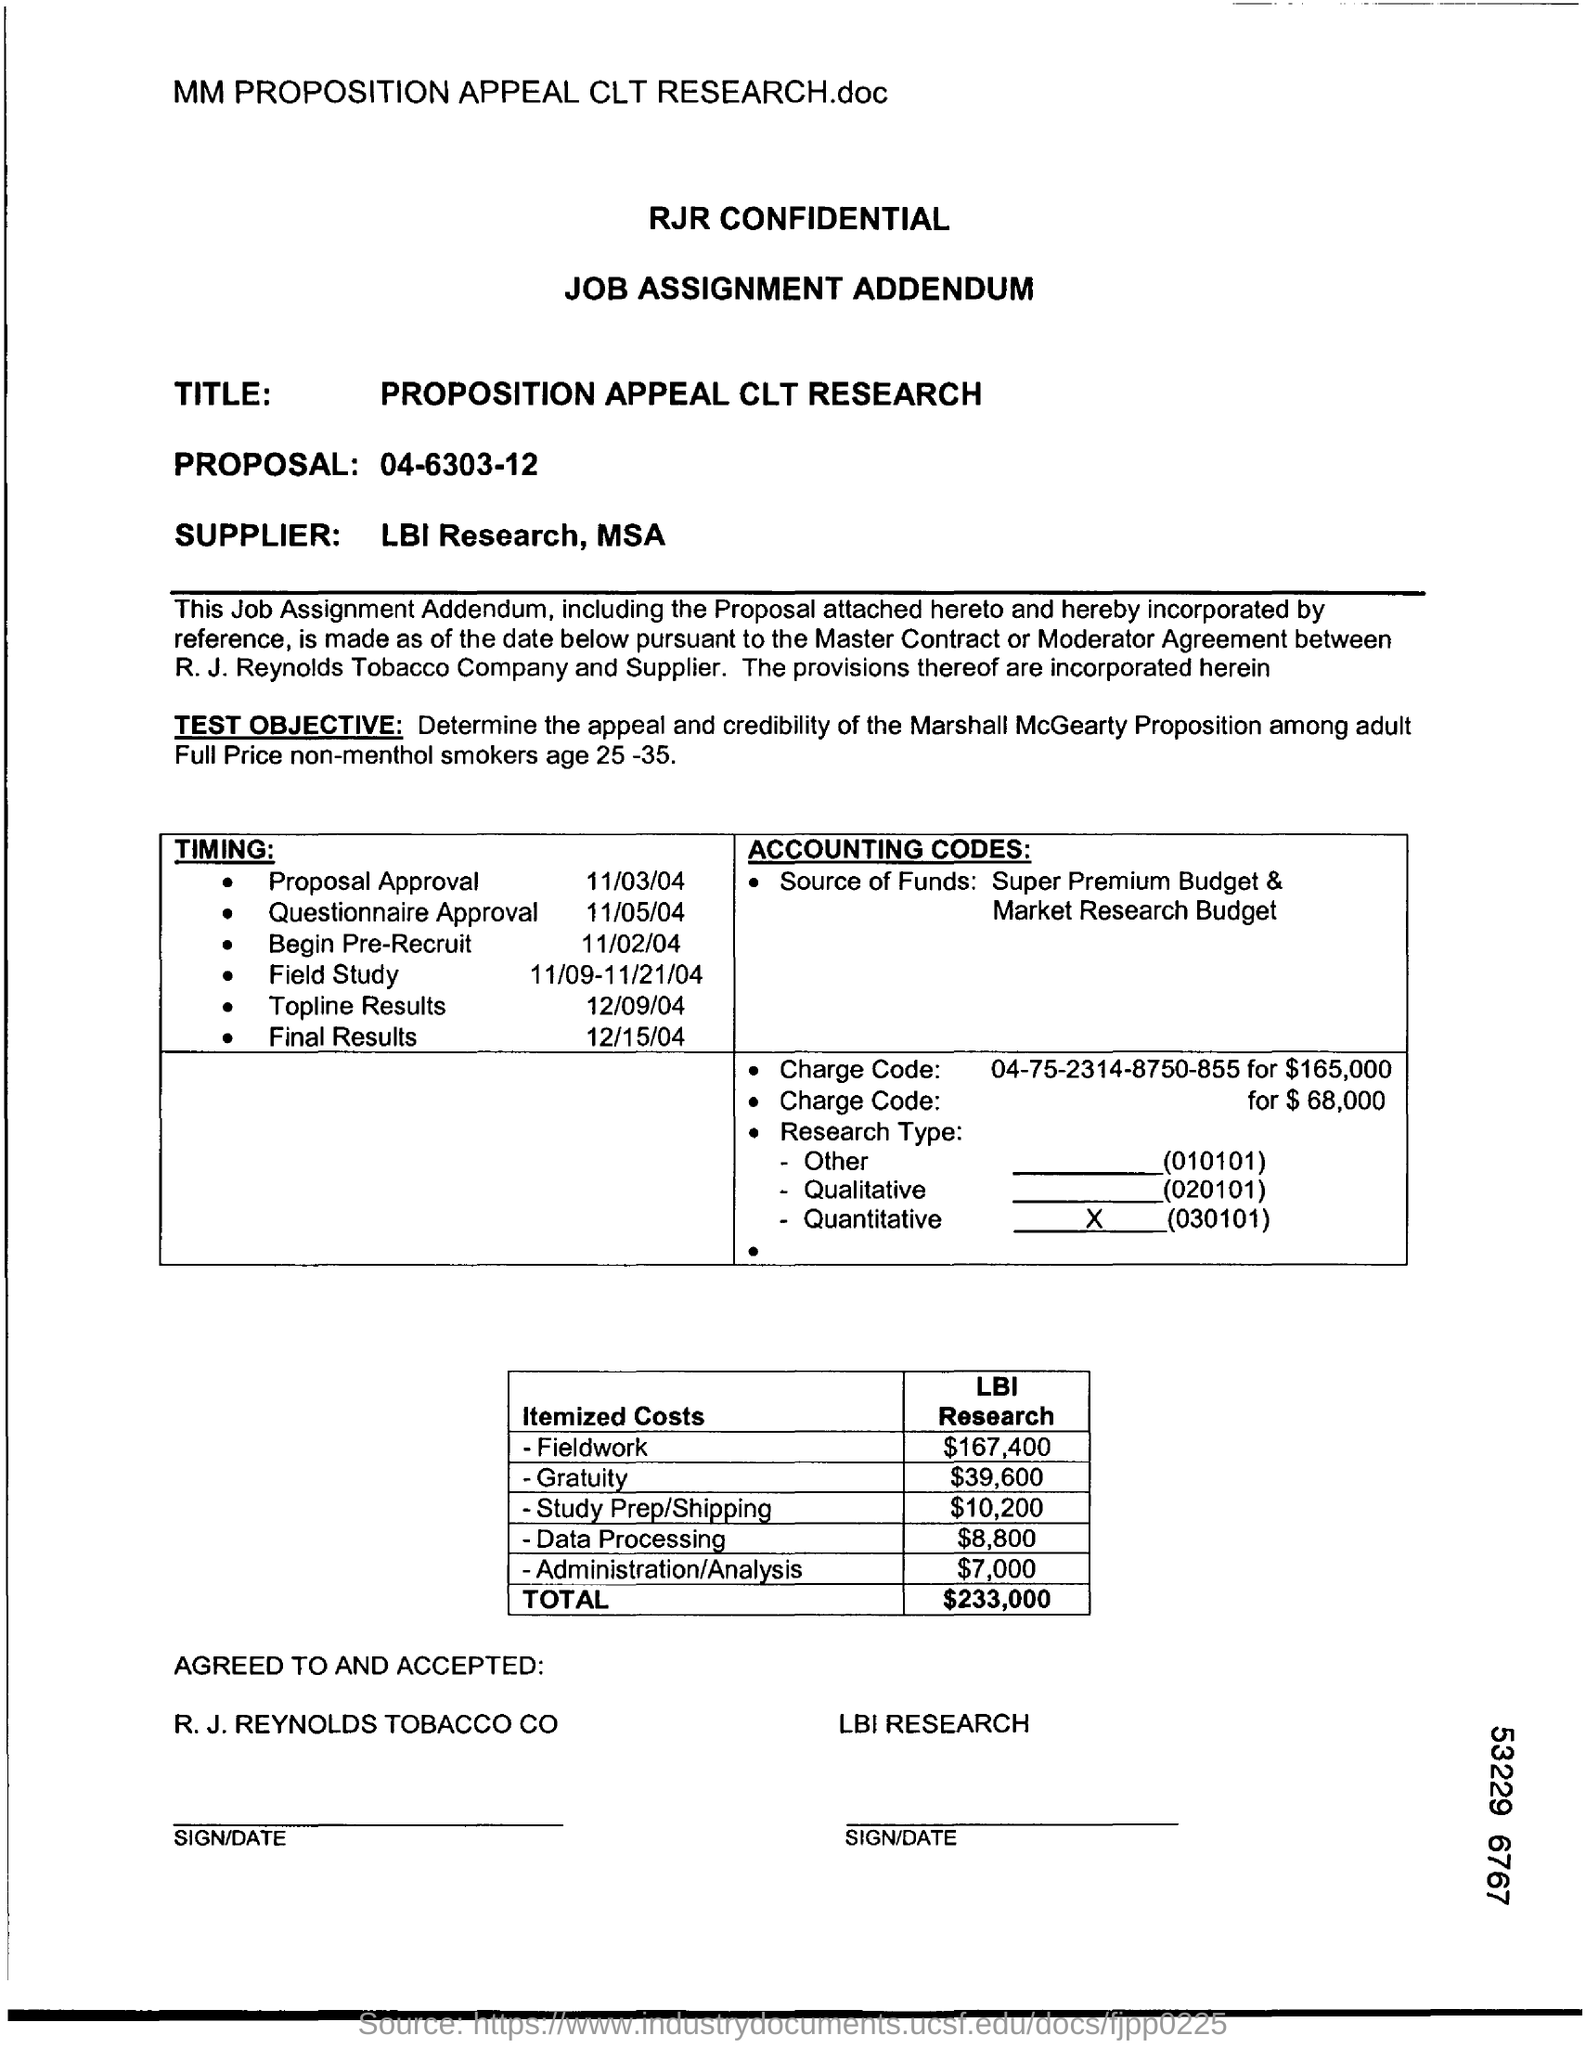Specify some key components in this picture. LBI Research and MSA are the suppliers of the proposed solution. The timing for proposal approval is 11/03/04. The itemized costs for data processing are estimated to be $8,800. The timing for the release of topline results for a project is scheduled for December 9, 2004. 